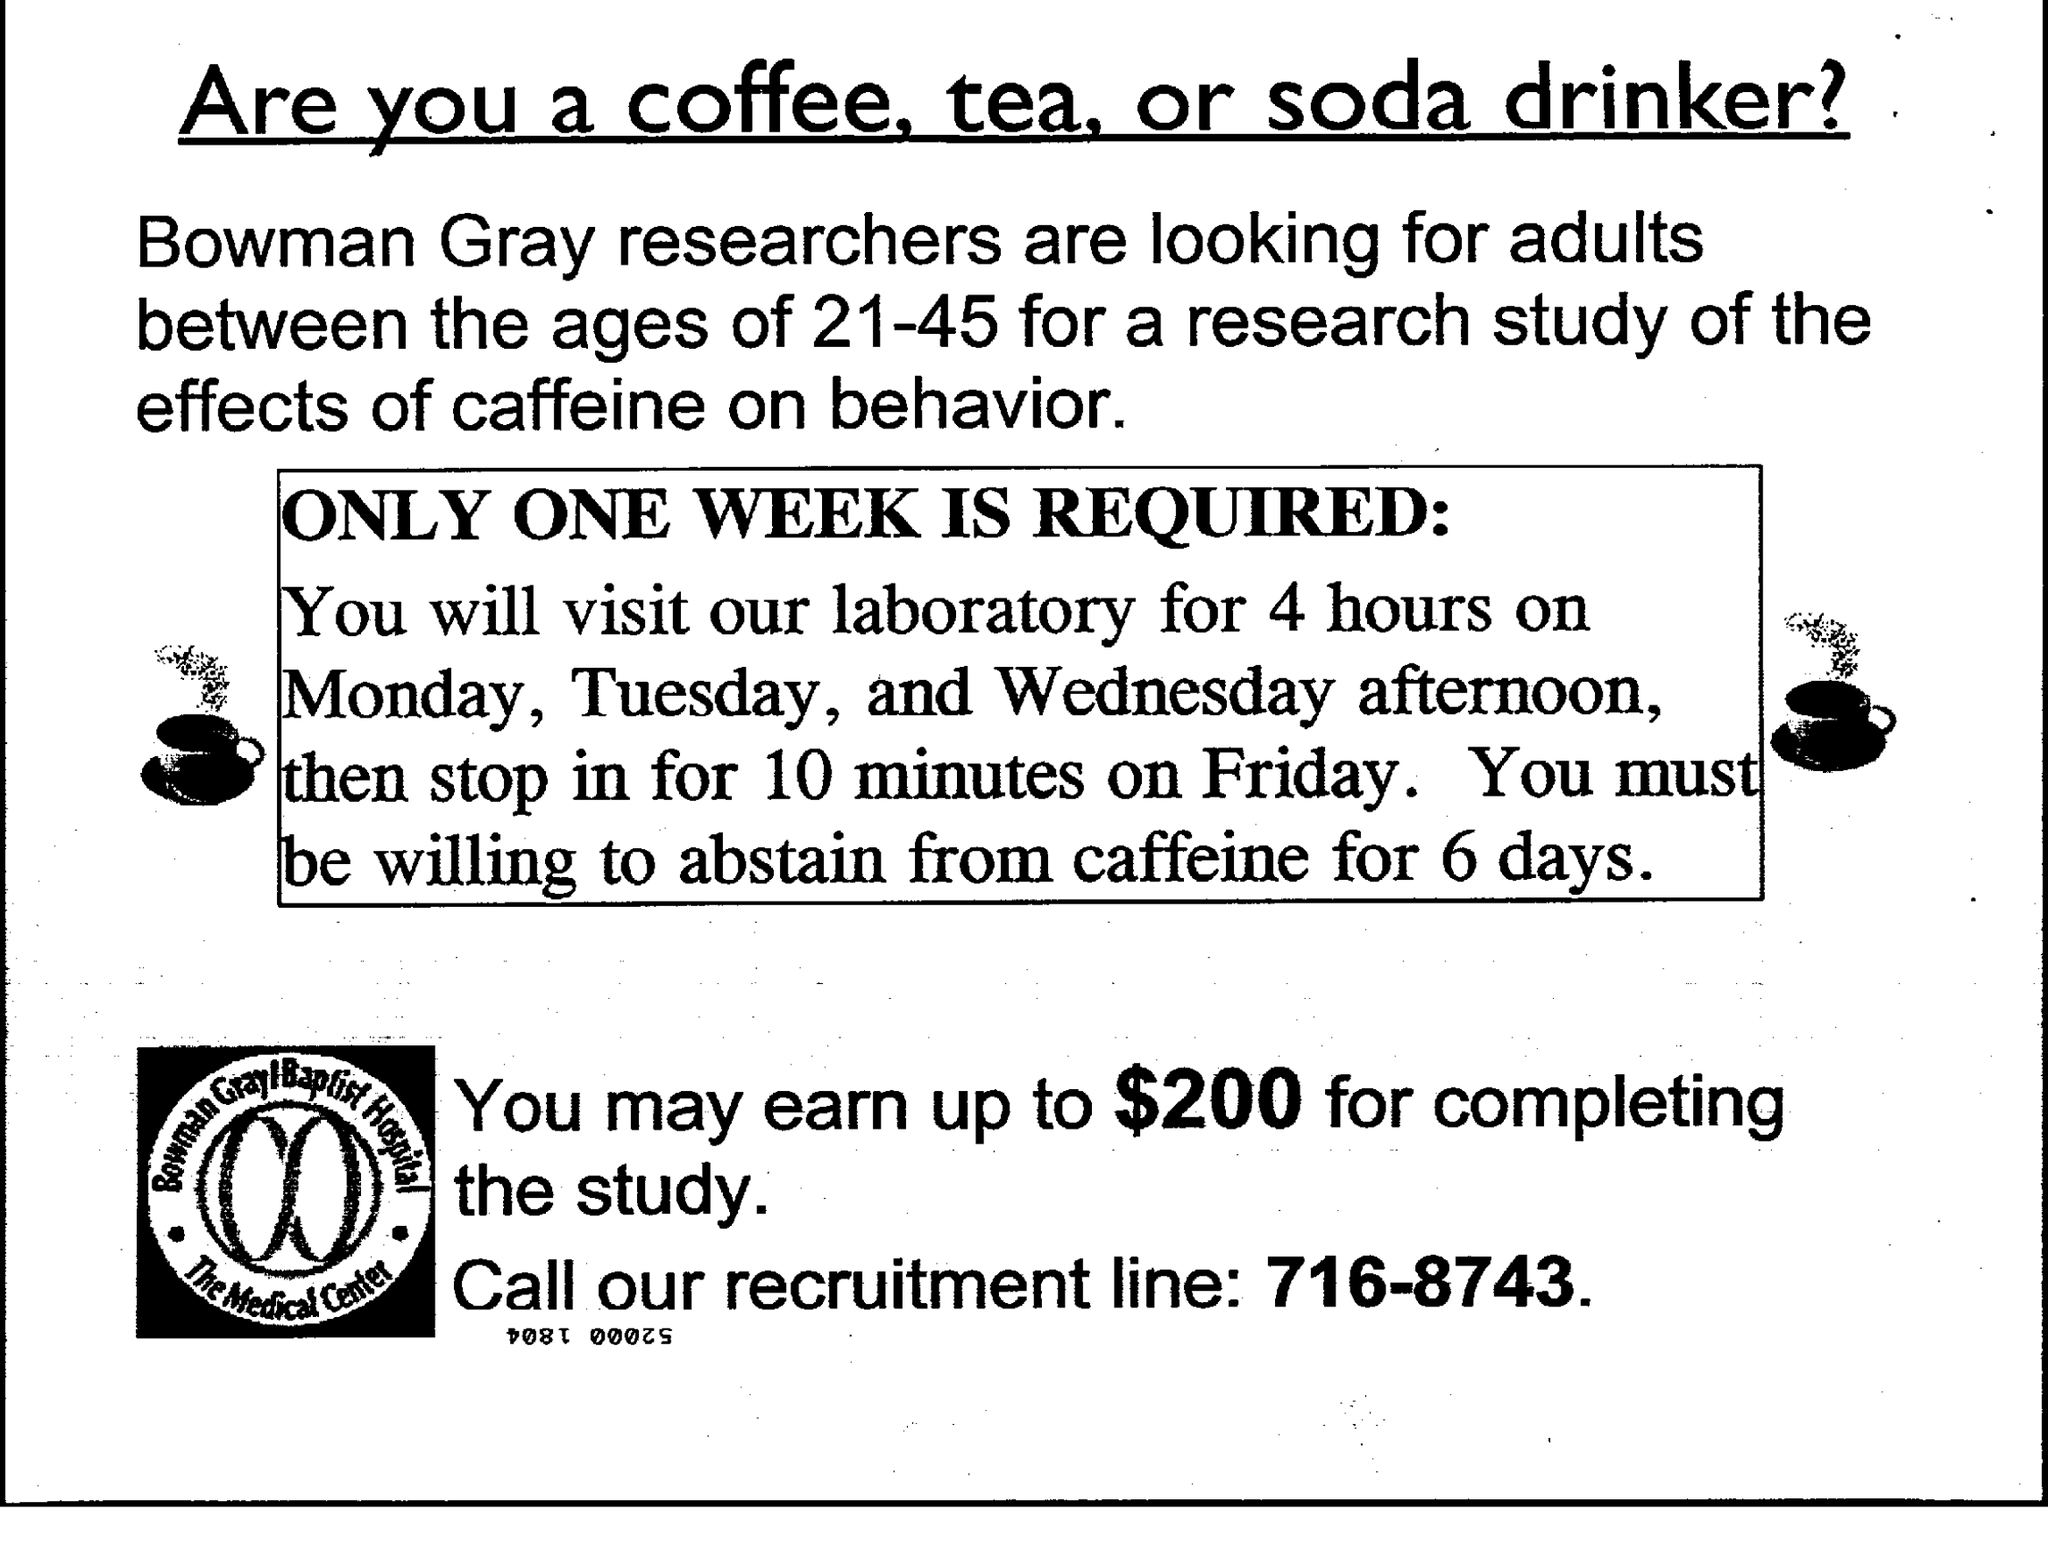Give some essential details in this illustration. The recruitment line number given is 716-8743. It is recommended to abstain from caffeine for a period of six days. It is possible to earn up to $200 for completing the study. The document title is "What is the document title?" and the speaker is asking if the listener is a coffee, tea, or soda drinker. You should visit the laboratory for a total of 4 hours from Monday to Wednesday. 